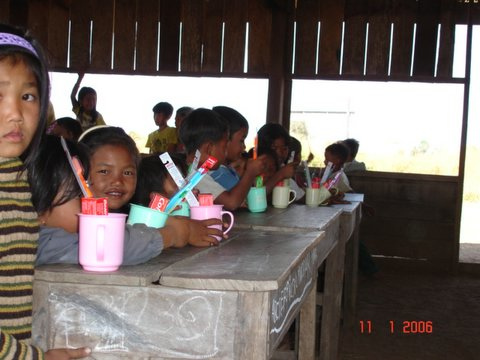Please transcribe the text in this image. 11 1 2006 